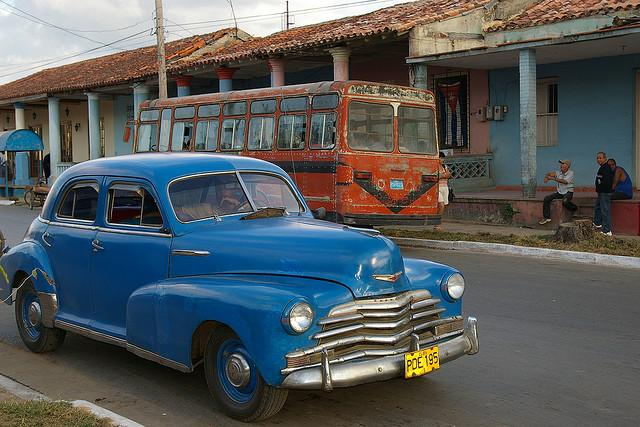Why are the vehicles so old? Please explain your reasoning. cuban embargo. Old cars are in the street with worn buildings behind that are lightly colored with metal roofs. 